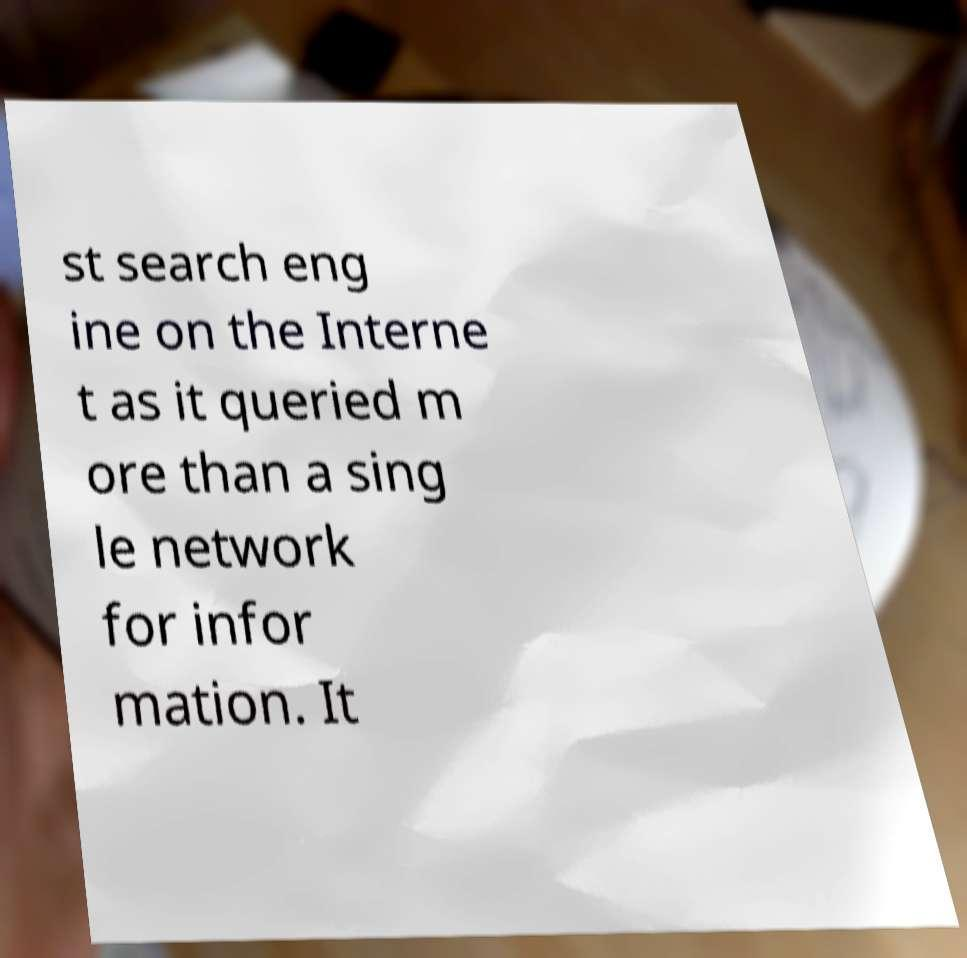Please read and relay the text visible in this image. What does it say? st search eng ine on the Interne t as it queried m ore than a sing le network for infor mation. It 